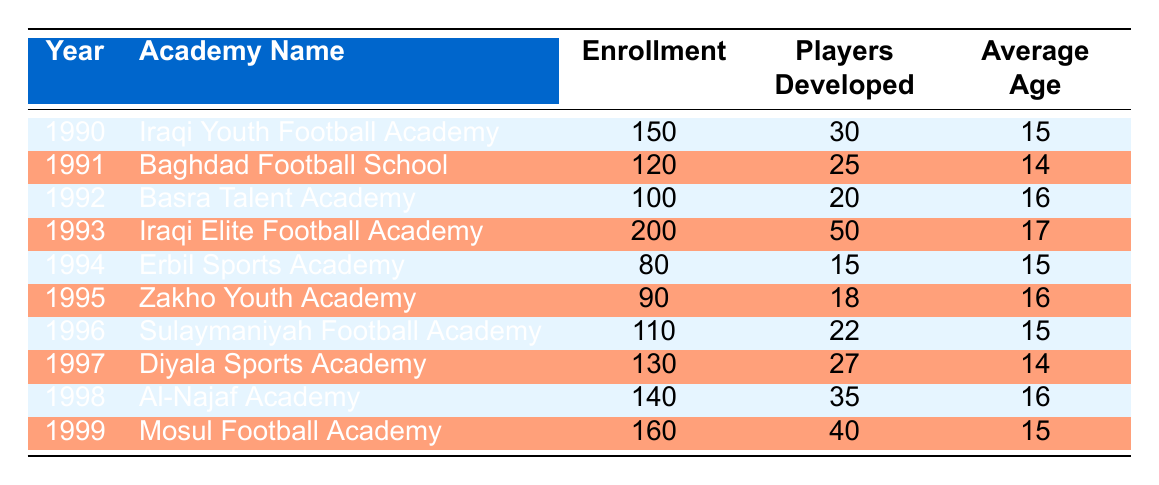What was the highest player enrollment in a single academy during the 1990s? The highest player enrollment is found in the year 1993 at the Iraqi Elite Football Academy, where the enrollment was 200 players.
Answer: 200 Which academy had the highest number of players developed in 1993? In 1993, the Iraqi Elite Football Academy had the highest number of players developed, which was 50.
Answer: 50 What is the average enrollment of players across all academies from 1990 to 1999? To find the average enrollment, we sum up all the enrollments: (150 + 120 + 100 + 200 + 80 + 90 + 110 + 130 + 140 + 160) = 1,280. There are 10 academies, so the average enrollment is 1280 / 10 = 128.
Answer: 128 Did the number of players developed increase from 1990 to 1999? Analyzing the development numbers: 30 (1990), 25 (1991), 20 (1992), 50 (1993), 15 (1994), 18 (1995), 22 (1996), 27 (1997), 35 (1998), 40 (1999), we see a pattern of fluctuation without a consistent increase. Hence, the answer is no.
Answer: No What was the average age of players developed at the Baghdad Football School? The average age of players developed at the Baghdad Football School in 1991 was 14, as indicated directly in the table.
Answer: 14 How many players were developed at the lowest enrolling academy in 1994? The lowest enrollment in 1994 was at Erbil Sports Academy with 80 players enrolled, and they developed 15 players.
Answer: 15 Which academy had a notable player named Falah Jassem? The academy with a notable player named Falah Jassem is the Iraqi Elite Football Academy, mentioned in the year 1993.
Answer: Iraqi Elite Football Academy Was the average age of players developed generally older in 1993 compared to 1992? In 1992, the average age was 16, and in 1993 it was 17. Since 17 is greater than 16, the players were older in 1993 compared to 1992.
Answer: Yes In which year did the Al-Najaf Academy develop the most players compared to the previous year? The Al-Najaf Academy developed 35 players in 1998, which is an increase from 27 players at the Diyala Sports Academy in 1997. This is the largest increase recorded between two consecutive years.
Answer: 1998 